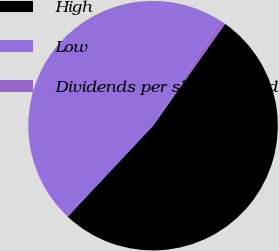Convert chart. <chart><loc_0><loc_0><loc_500><loc_500><pie_chart><fcel>High<fcel>Low<fcel>Dividends per share of Ford<nl><fcel>52.21%<fcel>47.13%<fcel>0.66%<nl></chart> 